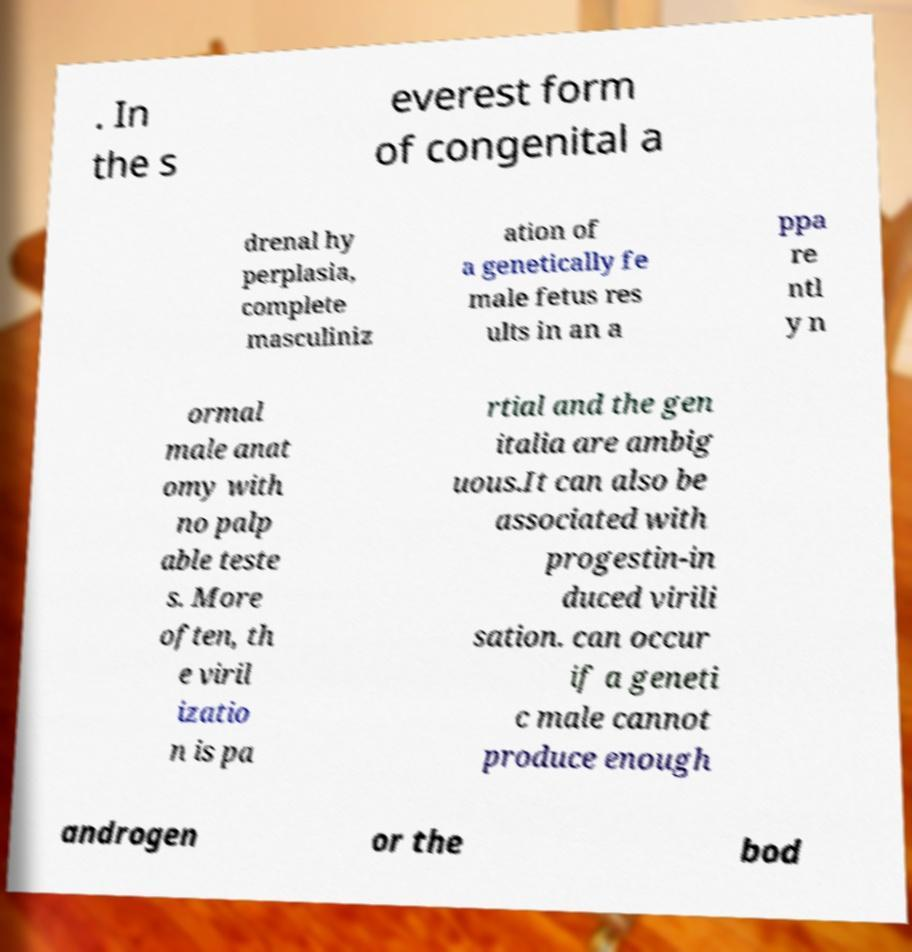Can you read and provide the text displayed in the image?This photo seems to have some interesting text. Can you extract and type it out for me? . In the s everest form of congenital a drenal hy perplasia, complete masculiniz ation of a genetically fe male fetus res ults in an a ppa re ntl y n ormal male anat omy with no palp able teste s. More often, th e viril izatio n is pa rtial and the gen italia are ambig uous.It can also be associated with progestin-in duced virili sation. can occur if a geneti c male cannot produce enough androgen or the bod 